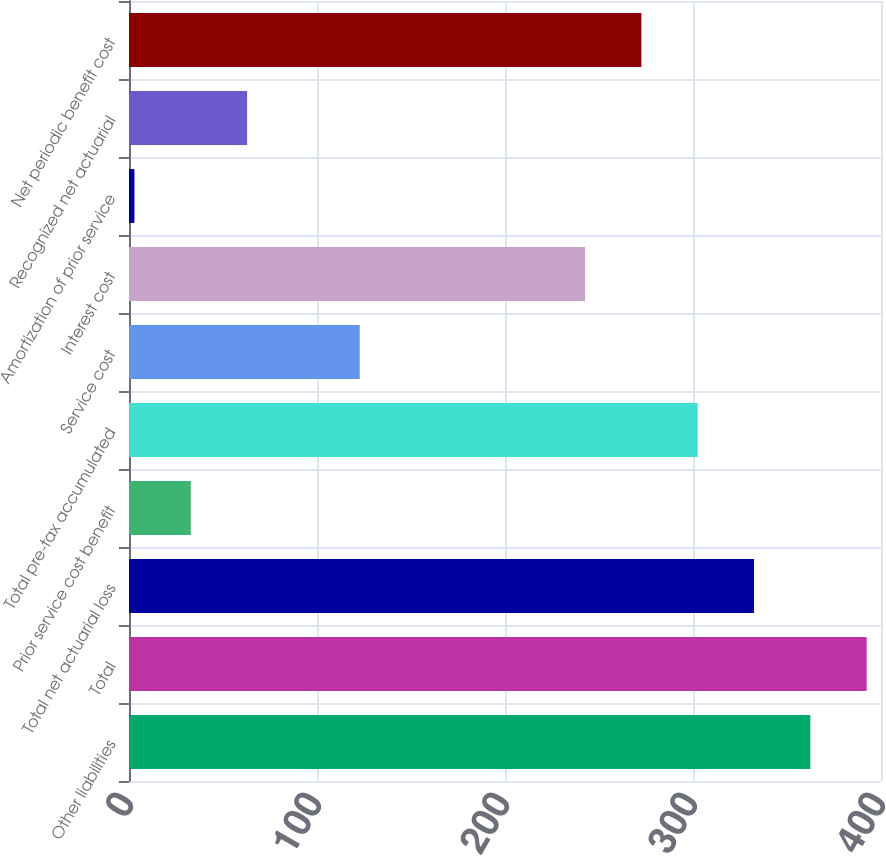Convert chart. <chart><loc_0><loc_0><loc_500><loc_500><bar_chart><fcel>Other liabilities<fcel>Total<fcel>Total net actuarial loss<fcel>Prior service cost benefit<fcel>Total pre-tax accumulated<fcel>Service cost<fcel>Interest cost<fcel>Amortization of prior service<fcel>Recognized net actuarial<fcel>Net periodic benefit cost<nl><fcel>362.42<fcel>392.38<fcel>332.46<fcel>32.86<fcel>302.5<fcel>122.74<fcel>242.58<fcel>2.9<fcel>62.82<fcel>272.54<nl></chart> 